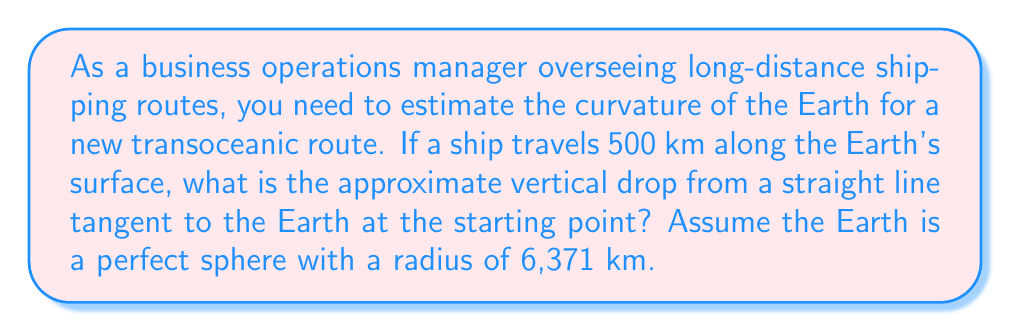Help me with this question. To solve this problem, we'll use trigonometry and the properties of a circle. Here's a step-by-step approach:

1. Visualize the problem:
   [asy]
   import geometry;
   
   size(200);
   pair O = (0,0);
   real R = 5;
   real theta = 4.5;
   
   draw(circle(O,R));
   pair A = R*dir(90);
   pair B = R*dir(90-theta);
   pair C = (B.x, A.y);
   
   draw(A--B--C--cycle);
   draw(O--A);
   draw(O--B);
   
   label("O", O, SW);
   label("A", A, N);
   label("B", B, SE);
   label("C", C, NE);
   label("R", (O--A)/2, NW);
   label("R", (O--B)/2, SE);
   label("s", (A--B)/2, E);
   label("h", (B--C)/2, E);
   
   draw(rightangle(O,B,C,20));
   [/asy]

2. Let's define our variables:
   $R$ = radius of the Earth = 6,371 km
   $s$ = surface distance traveled = 500 km
   $h$ = vertical drop (what we're solving for)
   $\theta$ = central angle (in radians)

3. Calculate the central angle $\theta$:
   $\theta = \frac{s}{R} = \frac{500}{6371} \approx 0.0785$ radians

4. In the right triangle OBC:
   $\cos(\theta) = \frac{R-h}{R}$

5. Solve for $h$:
   $$\begin{align}
   R-h &= R \cos(\theta) \\
   h &= R - R \cos(\theta) \\
   h &= R(1 - \cos(\theta))
   \end{align}$$

6. Calculate $h$:
   $$\begin{align}
   h &= 6371(1 - \cos(0.0785)) \\
   &\approx 6371(1 - 0.9969) \\
   &\approx 6371(0.0031) \\
   &\approx 19.75 \text{ km}
   \end{align}$$

Thus, the vertical drop is approximately 19.75 km.
Answer: The approximate vertical drop from a straight line tangent to the Earth at the starting point, after traveling 500 km along the Earth's surface, is 19.75 km. 